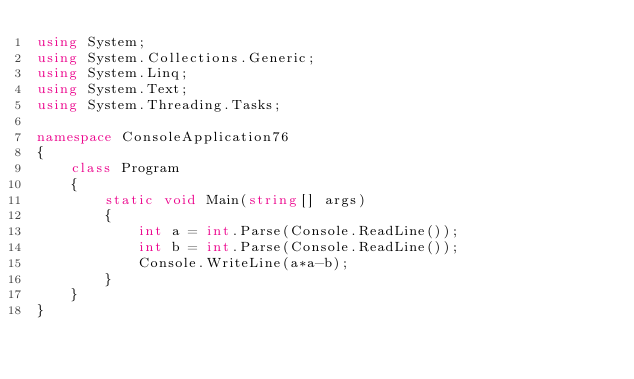<code> <loc_0><loc_0><loc_500><loc_500><_C#_>using System;
using System.Collections.Generic;
using System.Linq;
using System.Text;
using System.Threading.Tasks;
 
namespace ConsoleApplication76
{
    class Program
    {
        static void Main(string[] args)
        {
            int a = int.Parse(Console.ReadLine());
 			int b = int.Parse(Console.ReadLine());
 			Console.WriteLine(a*a-b);
        }
    }
}

</code> 